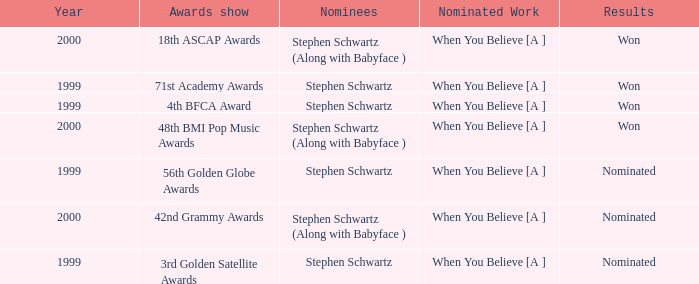What transpired at the 71st academy awards event in terms of results? Won. 